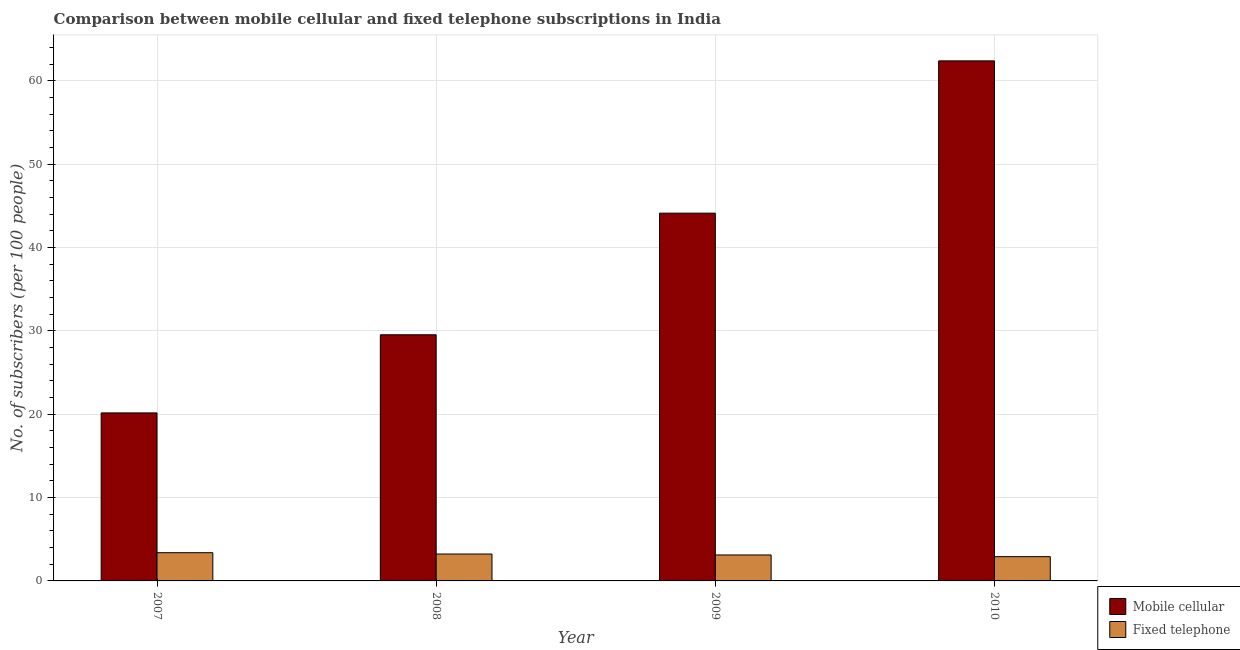How many different coloured bars are there?
Give a very brief answer. 2. Are the number of bars per tick equal to the number of legend labels?
Your answer should be compact. Yes. How many bars are there on the 4th tick from the left?
Offer a terse response. 2. How many bars are there on the 3rd tick from the right?
Make the answer very short. 2. What is the label of the 1st group of bars from the left?
Your response must be concise. 2007. What is the number of fixed telephone subscribers in 2008?
Provide a short and direct response. 3.23. Across all years, what is the maximum number of mobile cellular subscribers?
Your answer should be compact. 62.39. Across all years, what is the minimum number of mobile cellular subscribers?
Make the answer very short. 20.16. What is the total number of mobile cellular subscribers in the graph?
Make the answer very short. 156.2. What is the difference between the number of mobile cellular subscribers in 2008 and that in 2009?
Offer a terse response. -14.59. What is the difference between the number of mobile cellular subscribers in 2010 and the number of fixed telephone subscribers in 2007?
Offer a very short reply. 42.23. What is the average number of fixed telephone subscribers per year?
Your response must be concise. 3.16. In how many years, is the number of fixed telephone subscribers greater than 54?
Offer a very short reply. 0. What is the ratio of the number of fixed telephone subscribers in 2007 to that in 2010?
Make the answer very short. 1.16. Is the difference between the number of mobile cellular subscribers in 2009 and 2010 greater than the difference between the number of fixed telephone subscribers in 2009 and 2010?
Your answer should be very brief. No. What is the difference between the highest and the second highest number of fixed telephone subscribers?
Your answer should be very brief. 0.16. What is the difference between the highest and the lowest number of fixed telephone subscribers?
Offer a very short reply. 0.48. In how many years, is the number of mobile cellular subscribers greater than the average number of mobile cellular subscribers taken over all years?
Ensure brevity in your answer.  2. Is the sum of the number of fixed telephone subscribers in 2009 and 2010 greater than the maximum number of mobile cellular subscribers across all years?
Keep it short and to the point. Yes. What does the 1st bar from the left in 2010 represents?
Ensure brevity in your answer.  Mobile cellular. What does the 1st bar from the right in 2008 represents?
Provide a short and direct response. Fixed telephone. How many bars are there?
Keep it short and to the point. 8. Are all the bars in the graph horizontal?
Provide a succinct answer. No. Does the graph contain any zero values?
Make the answer very short. No. Does the graph contain grids?
Provide a short and direct response. Yes. Where does the legend appear in the graph?
Give a very brief answer. Bottom right. What is the title of the graph?
Keep it short and to the point. Comparison between mobile cellular and fixed telephone subscriptions in India. What is the label or title of the Y-axis?
Give a very brief answer. No. of subscribers (per 100 people). What is the No. of subscribers (per 100 people) in Mobile cellular in 2007?
Give a very brief answer. 20.16. What is the No. of subscribers (per 100 people) of Fixed telephone in 2007?
Ensure brevity in your answer.  3.39. What is the No. of subscribers (per 100 people) in Mobile cellular in 2008?
Give a very brief answer. 29.53. What is the No. of subscribers (per 100 people) in Fixed telephone in 2008?
Keep it short and to the point. 3.23. What is the No. of subscribers (per 100 people) in Mobile cellular in 2009?
Give a very brief answer. 44.12. What is the No. of subscribers (per 100 people) of Fixed telephone in 2009?
Provide a succinct answer. 3.11. What is the No. of subscribers (per 100 people) of Mobile cellular in 2010?
Your answer should be compact. 62.39. What is the No. of subscribers (per 100 people) in Fixed telephone in 2010?
Offer a very short reply. 2.91. Across all years, what is the maximum No. of subscribers (per 100 people) in Mobile cellular?
Your answer should be compact. 62.39. Across all years, what is the maximum No. of subscribers (per 100 people) of Fixed telephone?
Offer a terse response. 3.39. Across all years, what is the minimum No. of subscribers (per 100 people) of Mobile cellular?
Ensure brevity in your answer.  20.16. Across all years, what is the minimum No. of subscribers (per 100 people) of Fixed telephone?
Give a very brief answer. 2.91. What is the total No. of subscribers (per 100 people) of Mobile cellular in the graph?
Provide a short and direct response. 156.2. What is the total No. of subscribers (per 100 people) of Fixed telephone in the graph?
Give a very brief answer. 12.64. What is the difference between the No. of subscribers (per 100 people) of Mobile cellular in 2007 and that in 2008?
Offer a terse response. -9.38. What is the difference between the No. of subscribers (per 100 people) in Fixed telephone in 2007 and that in 2008?
Make the answer very short. 0.16. What is the difference between the No. of subscribers (per 100 people) of Mobile cellular in 2007 and that in 2009?
Your answer should be compact. -23.96. What is the difference between the No. of subscribers (per 100 people) of Fixed telephone in 2007 and that in 2009?
Your response must be concise. 0.27. What is the difference between the No. of subscribers (per 100 people) in Mobile cellular in 2007 and that in 2010?
Make the answer very short. -42.23. What is the difference between the No. of subscribers (per 100 people) in Fixed telephone in 2007 and that in 2010?
Ensure brevity in your answer.  0.48. What is the difference between the No. of subscribers (per 100 people) of Mobile cellular in 2008 and that in 2009?
Ensure brevity in your answer.  -14.59. What is the difference between the No. of subscribers (per 100 people) of Fixed telephone in 2008 and that in 2009?
Offer a very short reply. 0.11. What is the difference between the No. of subscribers (per 100 people) of Mobile cellular in 2008 and that in 2010?
Your answer should be compact. -32.86. What is the difference between the No. of subscribers (per 100 people) of Fixed telephone in 2008 and that in 2010?
Give a very brief answer. 0.32. What is the difference between the No. of subscribers (per 100 people) in Mobile cellular in 2009 and that in 2010?
Your answer should be compact. -18.27. What is the difference between the No. of subscribers (per 100 people) of Fixed telephone in 2009 and that in 2010?
Your answer should be compact. 0.2. What is the difference between the No. of subscribers (per 100 people) of Mobile cellular in 2007 and the No. of subscribers (per 100 people) of Fixed telephone in 2008?
Your answer should be very brief. 16.93. What is the difference between the No. of subscribers (per 100 people) in Mobile cellular in 2007 and the No. of subscribers (per 100 people) in Fixed telephone in 2009?
Make the answer very short. 17.04. What is the difference between the No. of subscribers (per 100 people) of Mobile cellular in 2007 and the No. of subscribers (per 100 people) of Fixed telephone in 2010?
Your answer should be compact. 17.24. What is the difference between the No. of subscribers (per 100 people) in Mobile cellular in 2008 and the No. of subscribers (per 100 people) in Fixed telephone in 2009?
Offer a terse response. 26.42. What is the difference between the No. of subscribers (per 100 people) in Mobile cellular in 2008 and the No. of subscribers (per 100 people) in Fixed telephone in 2010?
Provide a succinct answer. 26.62. What is the difference between the No. of subscribers (per 100 people) of Mobile cellular in 2009 and the No. of subscribers (per 100 people) of Fixed telephone in 2010?
Give a very brief answer. 41.21. What is the average No. of subscribers (per 100 people) of Mobile cellular per year?
Provide a succinct answer. 39.05. What is the average No. of subscribers (per 100 people) in Fixed telephone per year?
Your answer should be very brief. 3.16. In the year 2007, what is the difference between the No. of subscribers (per 100 people) of Mobile cellular and No. of subscribers (per 100 people) of Fixed telephone?
Provide a short and direct response. 16.77. In the year 2008, what is the difference between the No. of subscribers (per 100 people) of Mobile cellular and No. of subscribers (per 100 people) of Fixed telephone?
Offer a very short reply. 26.3. In the year 2009, what is the difference between the No. of subscribers (per 100 people) of Mobile cellular and No. of subscribers (per 100 people) of Fixed telephone?
Provide a succinct answer. 41.01. In the year 2010, what is the difference between the No. of subscribers (per 100 people) of Mobile cellular and No. of subscribers (per 100 people) of Fixed telephone?
Keep it short and to the point. 59.48. What is the ratio of the No. of subscribers (per 100 people) of Mobile cellular in 2007 to that in 2008?
Your response must be concise. 0.68. What is the ratio of the No. of subscribers (per 100 people) of Fixed telephone in 2007 to that in 2008?
Your answer should be very brief. 1.05. What is the ratio of the No. of subscribers (per 100 people) in Mobile cellular in 2007 to that in 2009?
Offer a terse response. 0.46. What is the ratio of the No. of subscribers (per 100 people) of Fixed telephone in 2007 to that in 2009?
Provide a short and direct response. 1.09. What is the ratio of the No. of subscribers (per 100 people) in Mobile cellular in 2007 to that in 2010?
Ensure brevity in your answer.  0.32. What is the ratio of the No. of subscribers (per 100 people) in Fixed telephone in 2007 to that in 2010?
Make the answer very short. 1.16. What is the ratio of the No. of subscribers (per 100 people) of Mobile cellular in 2008 to that in 2009?
Ensure brevity in your answer.  0.67. What is the ratio of the No. of subscribers (per 100 people) of Fixed telephone in 2008 to that in 2009?
Offer a terse response. 1.04. What is the ratio of the No. of subscribers (per 100 people) in Mobile cellular in 2008 to that in 2010?
Keep it short and to the point. 0.47. What is the ratio of the No. of subscribers (per 100 people) in Fixed telephone in 2008 to that in 2010?
Your response must be concise. 1.11. What is the ratio of the No. of subscribers (per 100 people) of Mobile cellular in 2009 to that in 2010?
Your answer should be very brief. 0.71. What is the ratio of the No. of subscribers (per 100 people) of Fixed telephone in 2009 to that in 2010?
Give a very brief answer. 1.07. What is the difference between the highest and the second highest No. of subscribers (per 100 people) of Mobile cellular?
Your response must be concise. 18.27. What is the difference between the highest and the second highest No. of subscribers (per 100 people) in Fixed telephone?
Offer a very short reply. 0.16. What is the difference between the highest and the lowest No. of subscribers (per 100 people) of Mobile cellular?
Keep it short and to the point. 42.23. What is the difference between the highest and the lowest No. of subscribers (per 100 people) of Fixed telephone?
Make the answer very short. 0.48. 